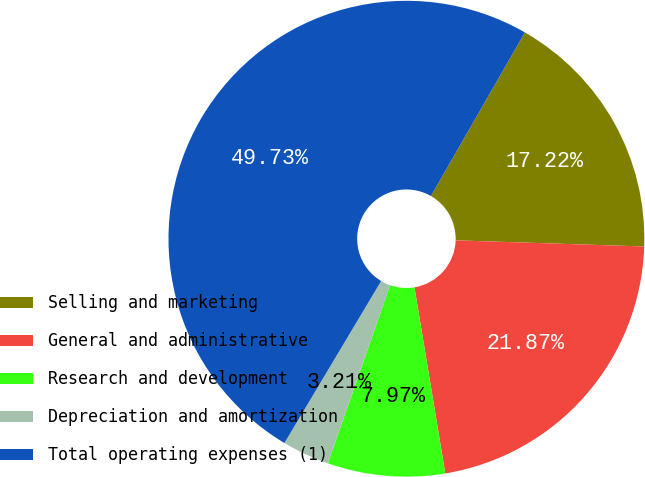<chart> <loc_0><loc_0><loc_500><loc_500><pie_chart><fcel>Selling and marketing<fcel>General and administrative<fcel>Research and development<fcel>Depreciation and amortization<fcel>Total operating expenses (1)<nl><fcel>17.22%<fcel>21.87%<fcel>7.97%<fcel>3.21%<fcel>49.73%<nl></chart> 